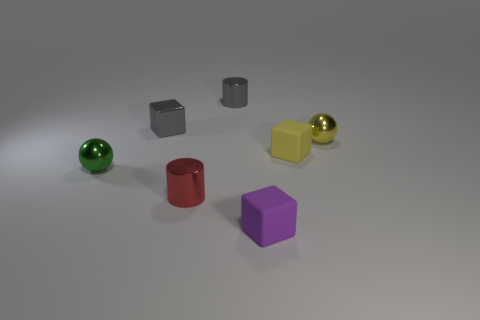What number of metallic things are the same color as the shiny block?
Your response must be concise. 1. There is a cylinder that is the same size as the red thing; what is its color?
Offer a terse response. Gray. There is a yellow metal sphere; what number of gray objects are in front of it?
Offer a very short reply. 0. Are there any rubber cubes?
Your response must be concise. Yes. How big is the sphere to the left of the matte thing behind the small shiny thing on the left side of the small gray block?
Your answer should be compact. Small. What number of other things are there of the same size as the yellow metal object?
Offer a very short reply. 6. How big is the cube in front of the red thing?
Ensure brevity in your answer.  Small. Do the block on the left side of the small gray cylinder and the gray cylinder have the same material?
Provide a short and direct response. Yes. What number of small things are in front of the small gray shiny cube and behind the yellow matte thing?
Offer a terse response. 1. Is the number of small metallic cylinders greater than the number of cubes?
Provide a succinct answer. No. 